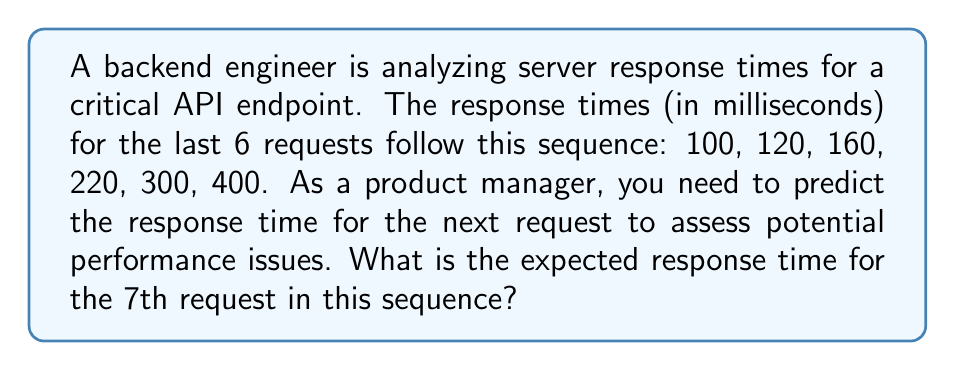Give your solution to this math problem. To predict the next number in this sequence, we need to identify the pattern:

1. Calculate the differences between consecutive terms:
   $120 - 100 = 20$
   $160 - 120 = 40$
   $220 - 160 = 60$
   $300 - 220 = 80$
   $400 - 300 = 100$

2. Observe that the differences are increasing by 20 each time:
   $20, 40, 60, 80, 100$

3. The pattern suggests that the next difference will be:
   $100 + 20 = 120$

4. Therefore, to find the 7th term, we add this difference to the 6th term:
   $400 + 120 = 520$

Thus, the expected response time for the 7th request is 520 milliseconds.

This exponential growth pattern ($a_n = a_1 \cdot r^{n-1}$, where $r = 1.2$) suggests that the server might be experiencing increasing load or resource constraints, potentially leading to performance issues.
Answer: 520 ms 